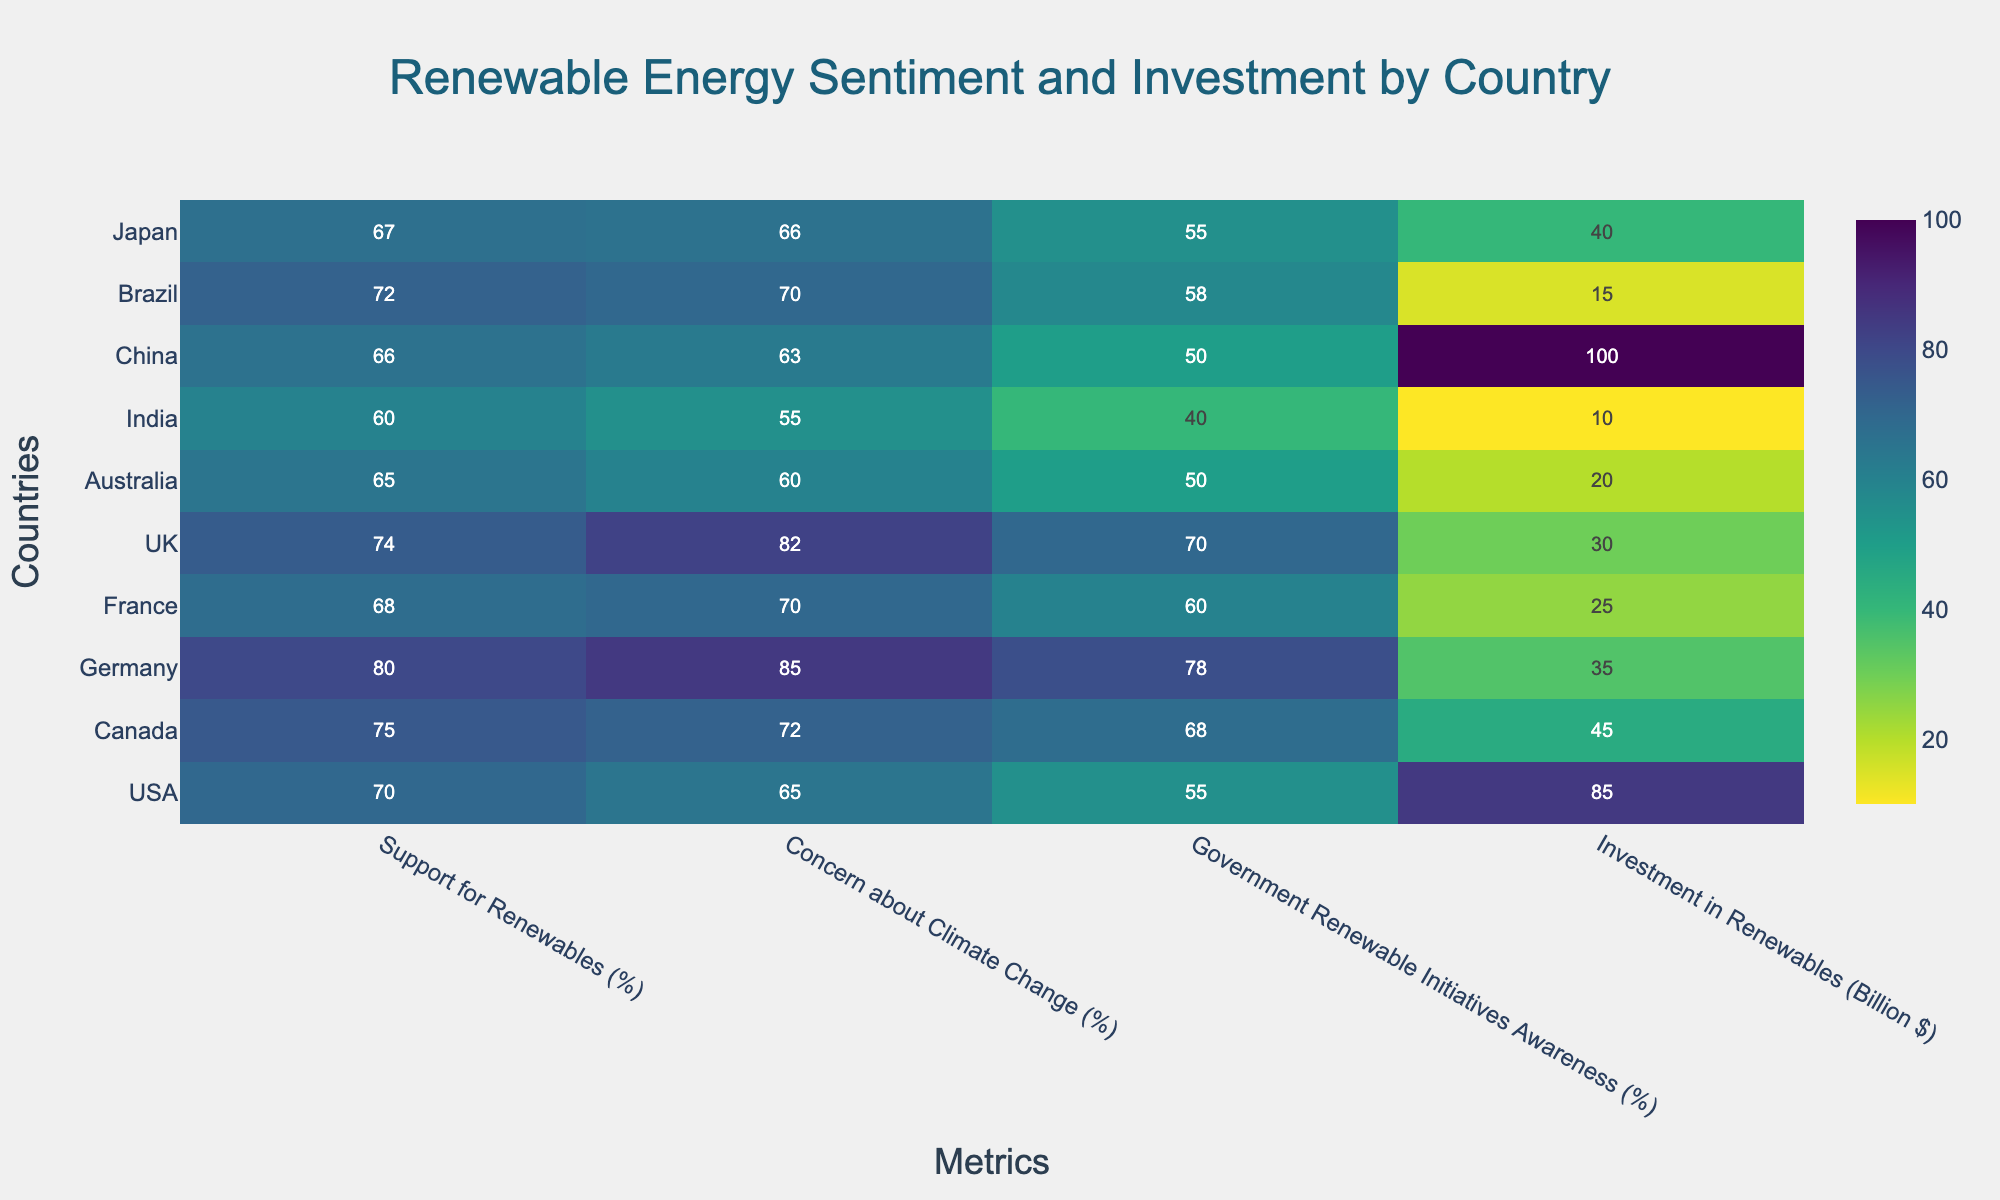What is the title of the heatmap? The title is prominently displayed at the top of the heatmap. Reading it provides the overall context of the data representation.
Answer: Renewable Energy Sentiment and Investment by Country Which country has the highest support for renewables? To find the country with the highest support for renewables, look for the maximum value in the "Support for Renewables (%)" column.
Answer: Germany How much does the USA invest in renewables compared to China? Compare the values in the "Investment in Renewables (Billion $)" row for both the USA and China. The USA has 85 billion $ and China has 100 billion $. So, China invests more by 15 billion $.
Answer: China invests 15 billion $ more than the USA Which country shows the lowest awareness of government renewable initiatives? Look for the minimum value in the "Government Renewable Initiatives Awareness (%)" column.
Answer: India What is the average concern about climate change across all countries? Add up all the percentages in the "Concern about Climate Change (%)" column and divide by the number of countries (10). (65 + 72 + 85 + 70 + 82 + 60 + 55 + 63 + 70 + 66) / 10 = 688 / 10 = 68.8
Answer: 68.8 Which two countries have similar levels of support for renewables? Look for pairs of similar values in the "Support for Renewables (%)" column. Japan and France have similar percentages, 67% and 68% respectively.
Answer: Japan and France What is the difference in government renewable initiatives awareness between Canada and Australia? Subtract the "Government Renewable Initiatives Awareness (%)" value of Australia (50%) from that of Canada (68%). 68% - 50% = 18%
Answer: 18% Which country has the lowest investment in renewables? Identify the minimum value in the "Investment in Renewables (Billion $)" column.
Answer: India Is there any country where support for renewables is below 60%? Look through the "Support for Renewables (%)" column to see if any value is below 60%. According to the data, the lowest support is 60% (India).
Answer: No Which metric shows the highest variability among countries? Determine which column has the widest range by subtracting the minimum value from the maximum value for each metric. "Investment in Renewables" ranges from 10 billion $ to 100 billion $, a 90 billion $ difference, which is the highest range.
Answer: Investment in Renewables 